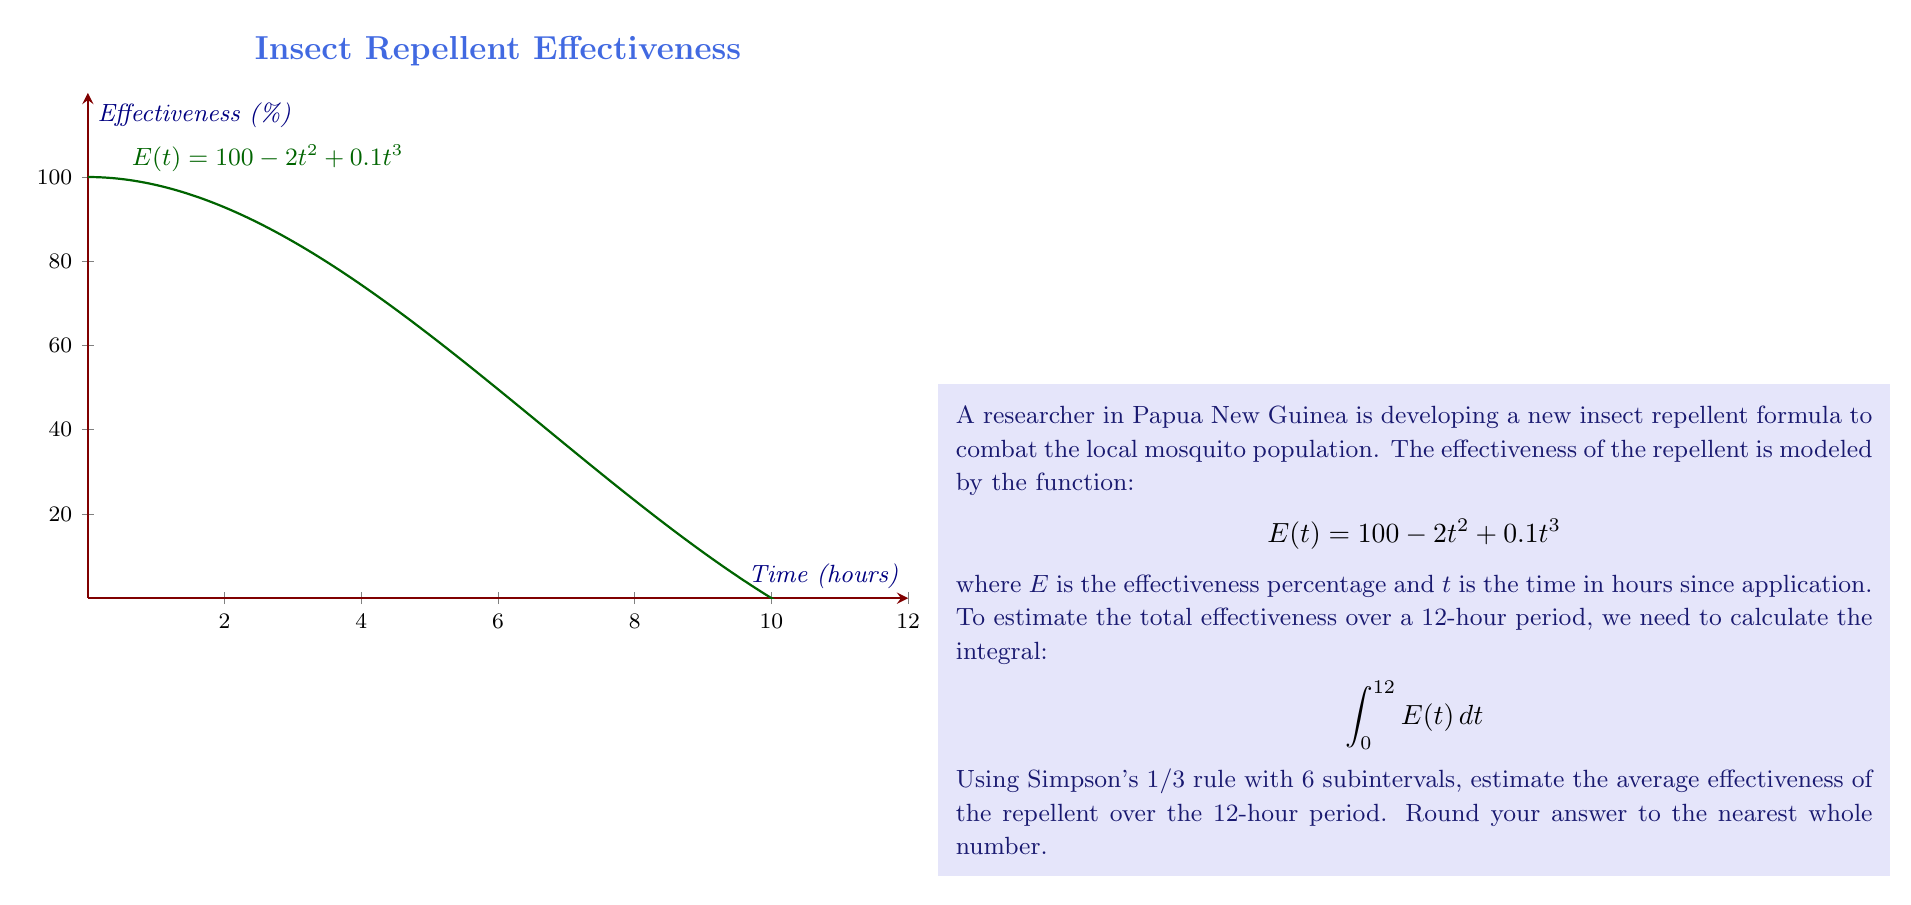Help me with this question. Let's approach this step-by-step using Simpson's 1/3 rule:

1) Simpson's 1/3 rule for 6 subintervals is given by:

   $$\int_a^b f(x) dx \approx \frac{h}{3}[f(x_0) + 4f(x_1) + 2f(x_2) + 4f(x_3) + 2f(x_4) + 4f(x_5) + f(x_6)]$$

   where $h = \frac{b-a}{6}$

2) In our case, $a=0$, $b=12$, so $h = \frac{12-0}{6} = 2$

3) We need to evaluate $E(t)$ at $t = 0, 2, 4, 6, 8, 10, 12$:

   $E(0) = 100 - 2(0)^2 + 0.1(0)^3 = 100$
   $E(2) = 100 - 2(2)^2 + 0.1(2)^3 = 92.8$
   $E(4) = 100 - 2(4)^2 + 0.1(4)^3 = 73.6$
   $E(6) = 100 - 2(6)^2 + 0.1(6)^3 = 46.4$
   $E(8) = 100 - 2(8)^2 + 0.1(8)^3 = 16.2$
   $E(10) = 100 - 2(10)^2 + 0.1(10)^3 = -10$
   $E(12) = 100 - 2(12)^2 + 0.1(12)^3 = -28.8$

4) Applying Simpson's 1/3 rule:

   $$\int_0^{12} E(t) dt \approx \frac{2}{3}[100 + 4(92.8) + 2(73.6) + 4(46.4) + 2(16.2) + 4(-10) + (-28.8)]$$

5) Calculating:

   $$\frac{2}{3}[100 + 371.2 + 147.2 + 185.6 + 32.4 - 40 - 28.8] = \frac{2}{3}[767.6] = 511.73$$

6) To find the average effectiveness, we divide by the time period (12 hours):

   $$\text{Average Effectiveness} = \frac{511.73}{12} \approx 42.64$$

7) Rounding to the nearest whole number: 43
Answer: 43% 